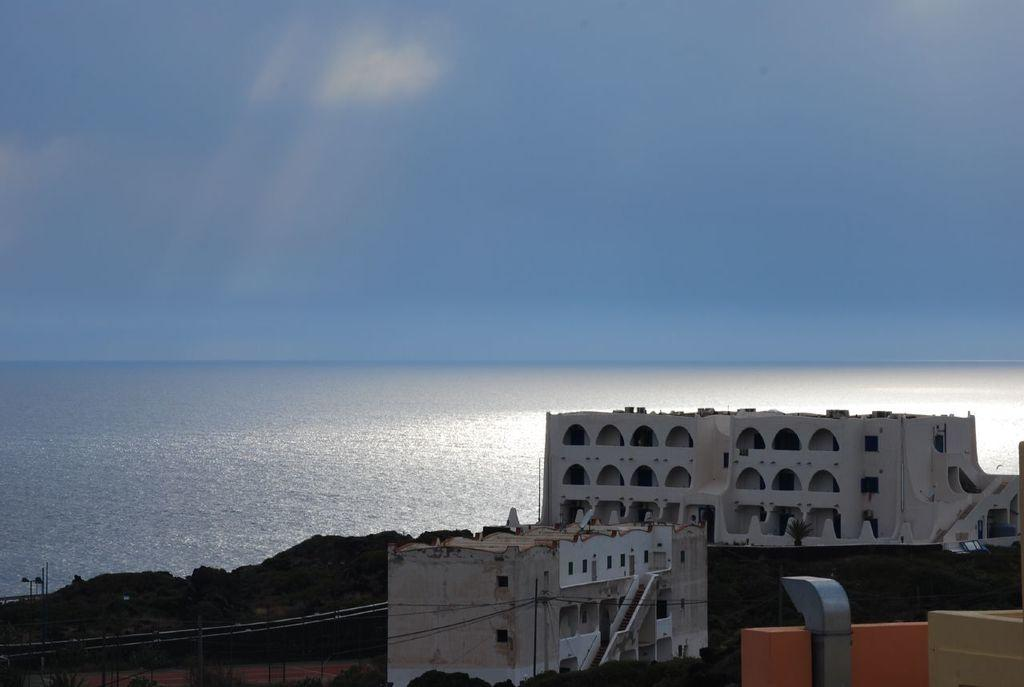What type of structures are located at the bottom of the image? There are houses at the bottom of the image. What natural features can be seen in the image? There are mountains and a river in the image. What man-made objects are present in the image? There are wires in the image. What is visible at the top of the image? The sky is visible at the top of the image. What type of competition is taking place in space in the image? There is no competition or space-related activity depicted in the image. What type of crime is being committed in the image? There is no crime or criminal activity depicted in the image. 